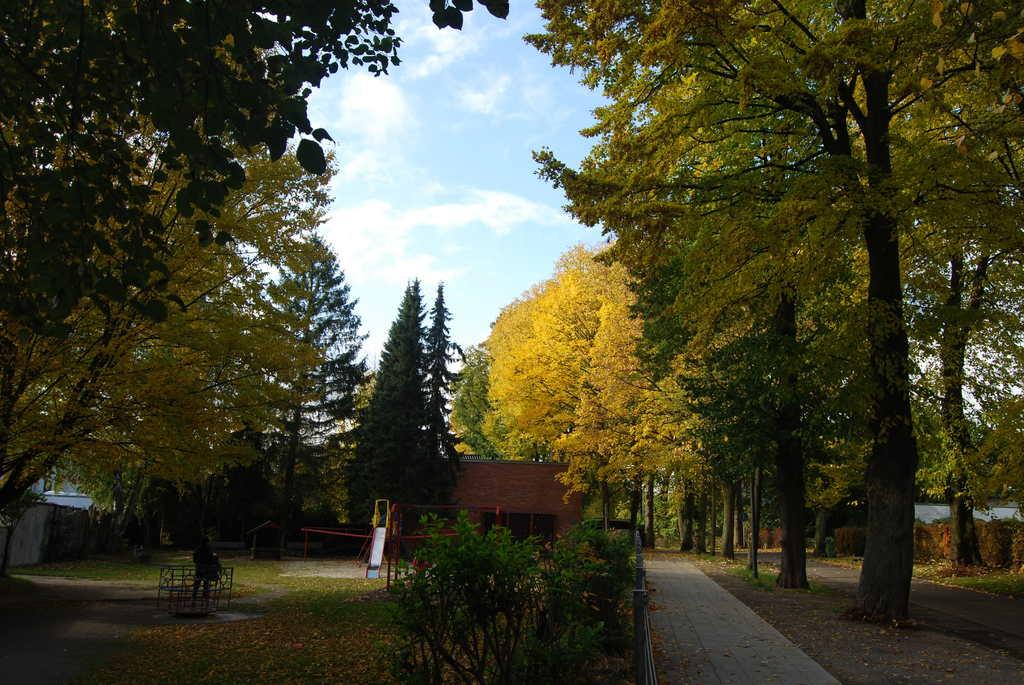What type of structure is present in the picture? There is a house in the picture. What other natural elements can be seen in the picture? There are plants and trees in the picture. What is visible in the background of the picture? The sky is visible in the background of the picture. What time of day is it in the picture, and how can we tell it's morning? The time of day cannot be determined from the image, as there are no specific clues or indicators of morning. Additionally, the provided facts do not mention any time-related information. 